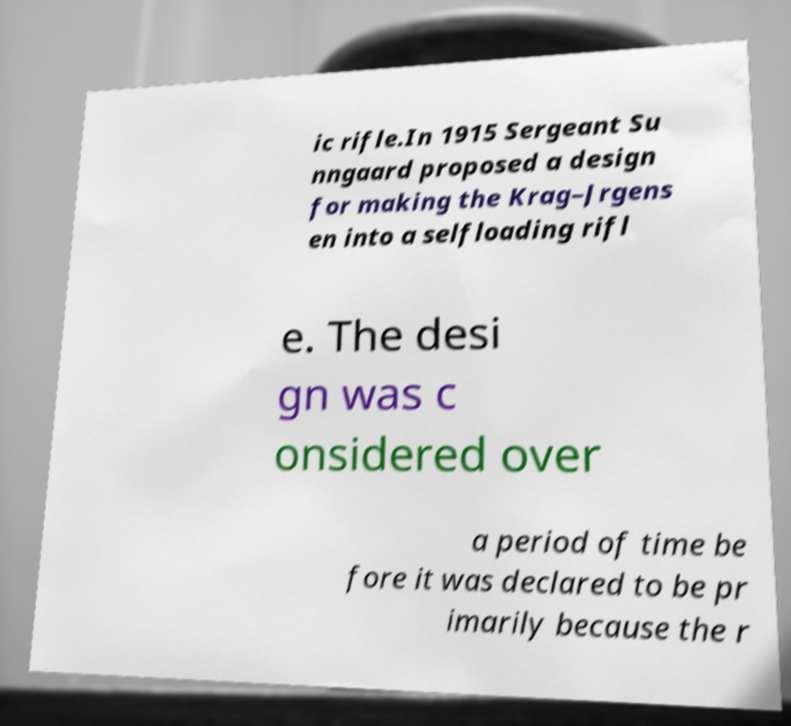Can you read and provide the text displayed in the image?This photo seems to have some interesting text. Can you extract and type it out for me? ic rifle.In 1915 Sergeant Su nngaard proposed a design for making the Krag–Jrgens en into a selfloading rifl e. The desi gn was c onsidered over a period of time be fore it was declared to be pr imarily because the r 